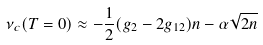Convert formula to latex. <formula><loc_0><loc_0><loc_500><loc_500>\nu _ { c } ( T = 0 ) \approx - \frac { 1 } { 2 } ( g _ { 2 } - 2 g _ { 1 2 } ) n - \alpha \sqrt { 2 n }</formula> 